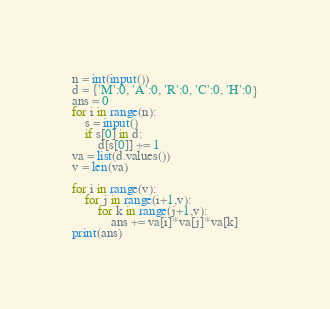<code> <loc_0><loc_0><loc_500><loc_500><_Python_>n = int(input())
d = {'M':0, 'A':0, 'R':0, 'C':0, 'H':0}
ans = 0
for i in range(n):
    s = input()
    if s[0] in d:
        d[s[0]] += 1
va = list(d.values())
v = len(va)

for i in range(v):
    for j in range(i+1,v):
        for k in range(j+1,v):
            ans += va[i]*va[j]*va[k]
print(ans)

</code> 